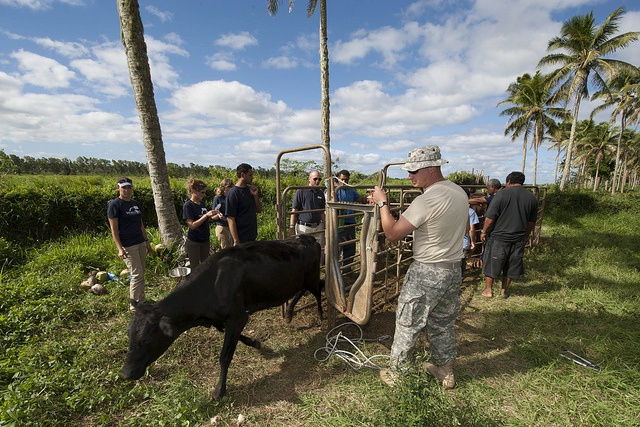Describe the objects in this image and their specific colors. I can see cow in darkgray, black, darkgreen, and gray tones, people in darkgray and gray tones, people in darkgray, black, gray, and brown tones, people in darkgray, black, and gray tones, and people in darkgray, black, maroon, gray, and olive tones in this image. 